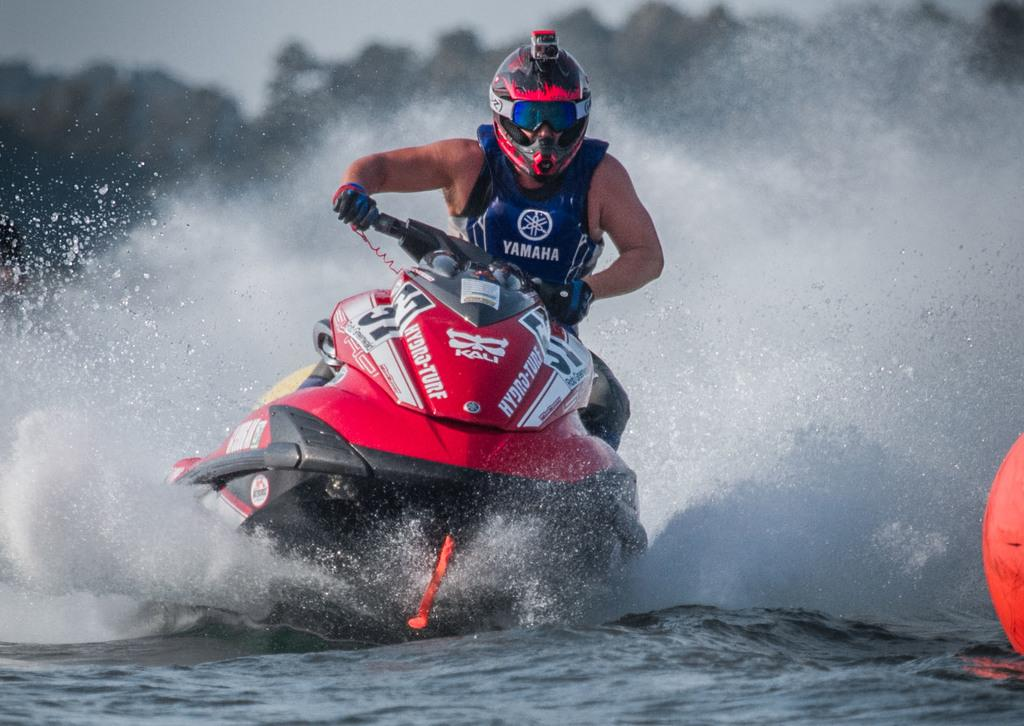What is the person in the image doing? The person is riding a jet ski in the image. What protective gear is the person wearing? The person is wearing a helmet, goggles, and gloves. Where is the jet ski located? The jet ski is on the water. What type of pan is hanging on the curtain in the image? There is no pan or curtain present in the image; it features a person riding a jet ski on the water. 